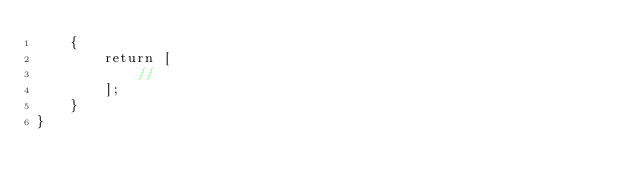Convert code to text. <code><loc_0><loc_0><loc_500><loc_500><_PHP_>    {
        return [
            //
        ];
    }
}
</code> 